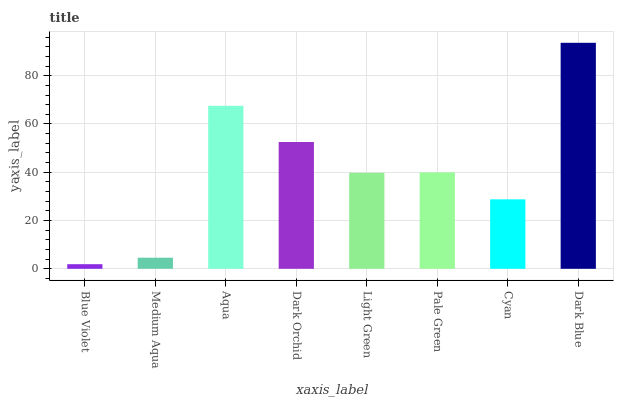Is Blue Violet the minimum?
Answer yes or no. Yes. Is Dark Blue the maximum?
Answer yes or no. Yes. Is Medium Aqua the minimum?
Answer yes or no. No. Is Medium Aqua the maximum?
Answer yes or no. No. Is Medium Aqua greater than Blue Violet?
Answer yes or no. Yes. Is Blue Violet less than Medium Aqua?
Answer yes or no. Yes. Is Blue Violet greater than Medium Aqua?
Answer yes or no. No. Is Medium Aqua less than Blue Violet?
Answer yes or no. No. Is Pale Green the high median?
Answer yes or no. Yes. Is Light Green the low median?
Answer yes or no. Yes. Is Dark Blue the high median?
Answer yes or no. No. Is Cyan the low median?
Answer yes or no. No. 